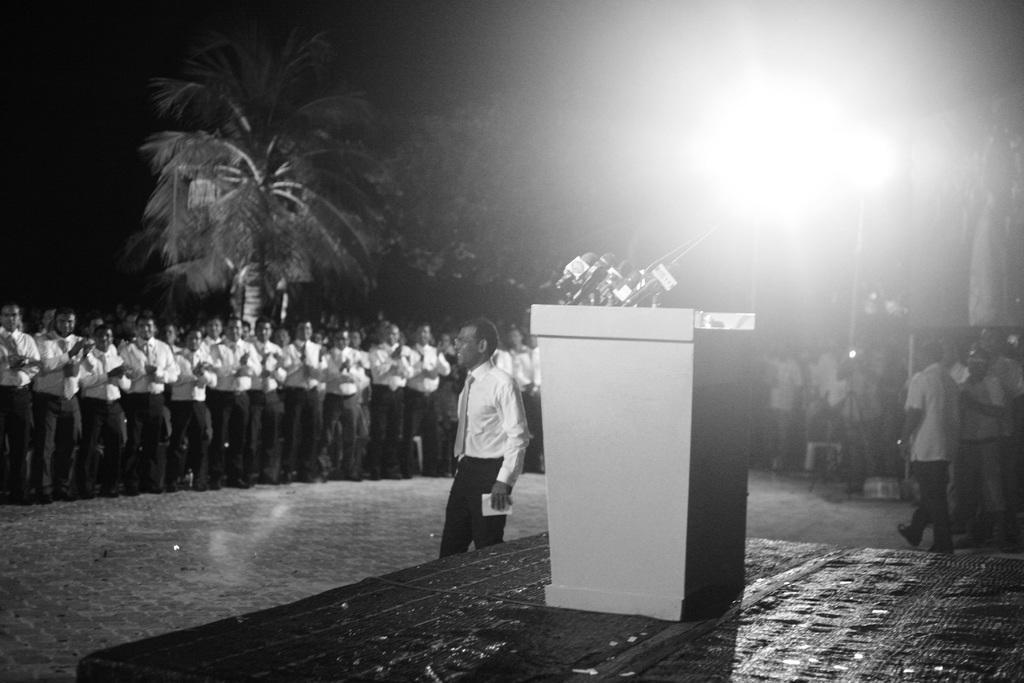Could you give a brief overview of what you see in this image? Here we can see a podium with microphones on the stage. In the middle, we can see a person is smiling and holding an object. On the right side, we can see a person is walking on the platform. Background we can see a group of people are standing and trees. 